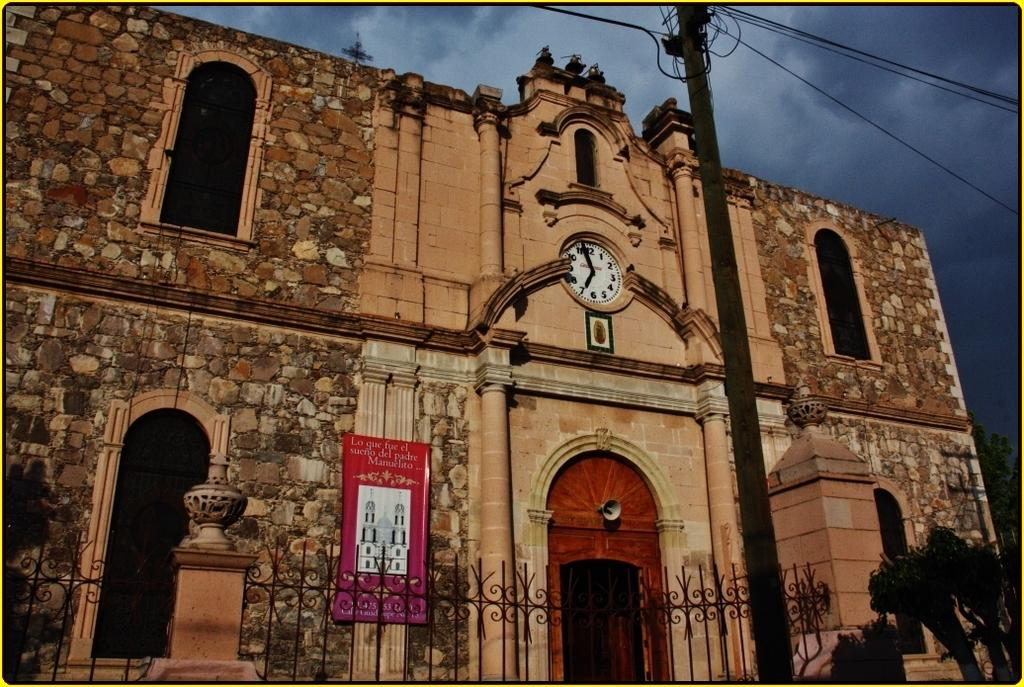<image>
Describe the image concisely. A large brick and stone building with a clock on the front that states that it is nearly 7 o'clock. 